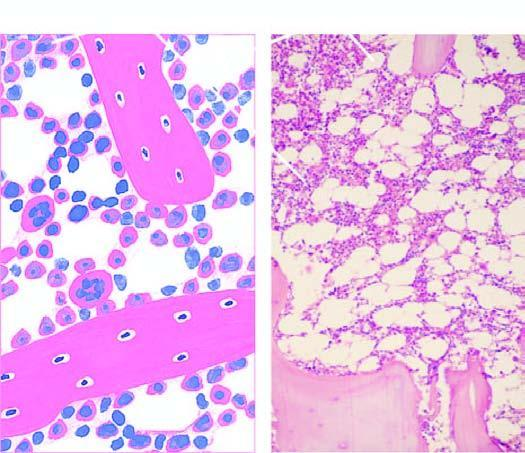what is normal bone marrow in an adultseen in after trephine biopsy?
Answer the question using a single word or phrase. A section after trephine biopsy 